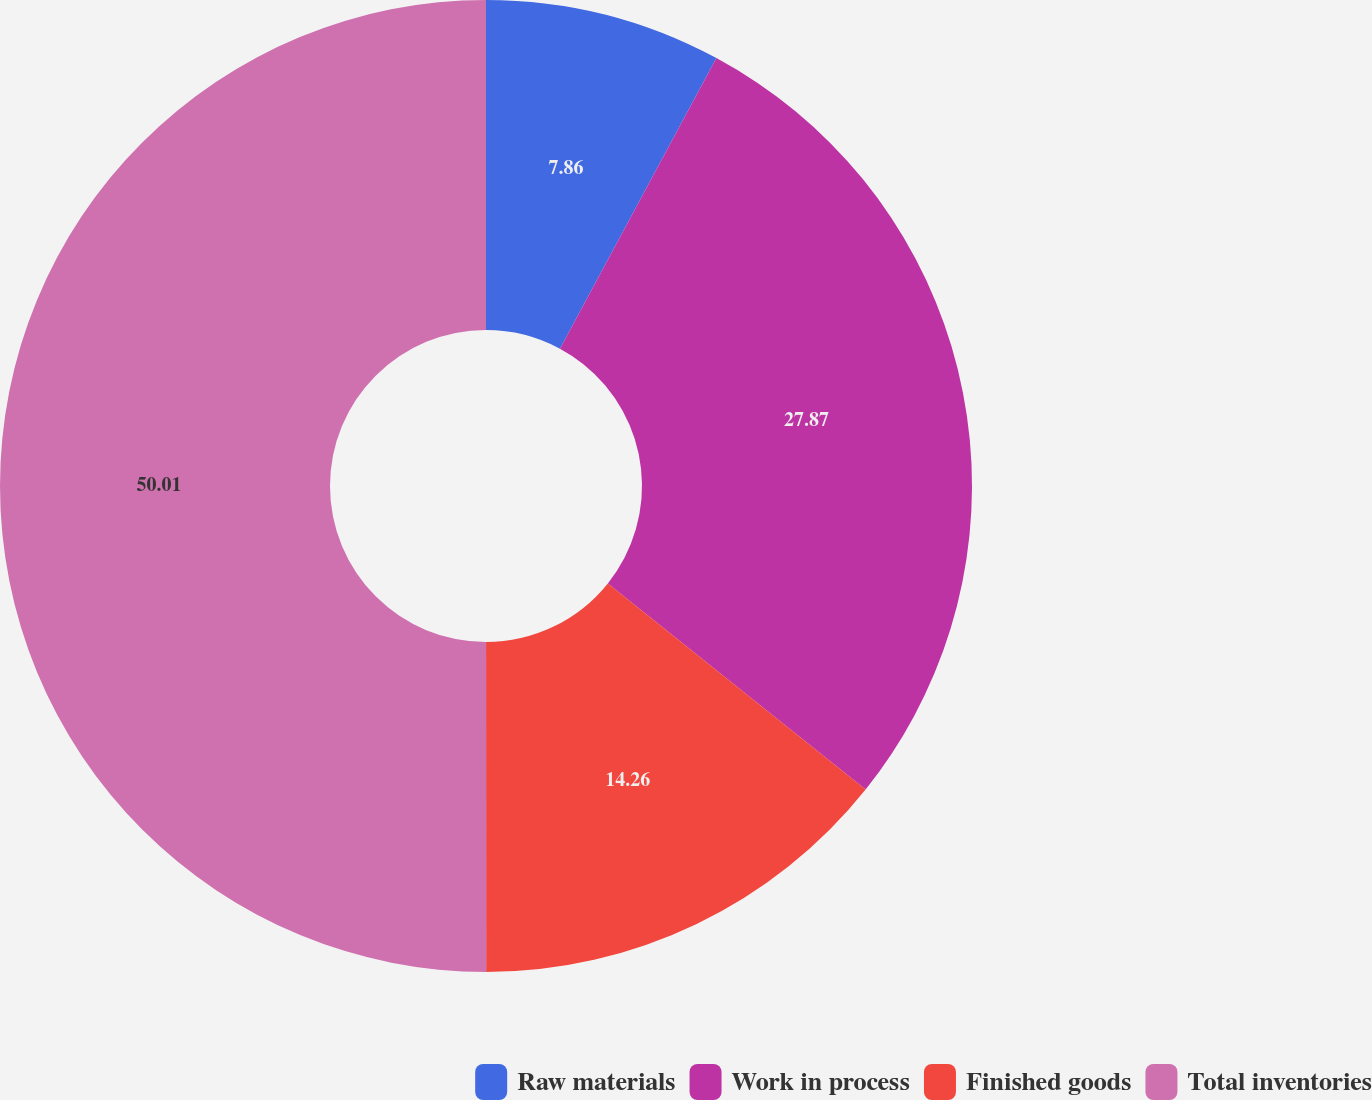Convert chart to OTSL. <chart><loc_0><loc_0><loc_500><loc_500><pie_chart><fcel>Raw materials<fcel>Work in process<fcel>Finished goods<fcel>Total inventories<nl><fcel>7.86%<fcel>27.87%<fcel>14.26%<fcel>50.0%<nl></chart> 